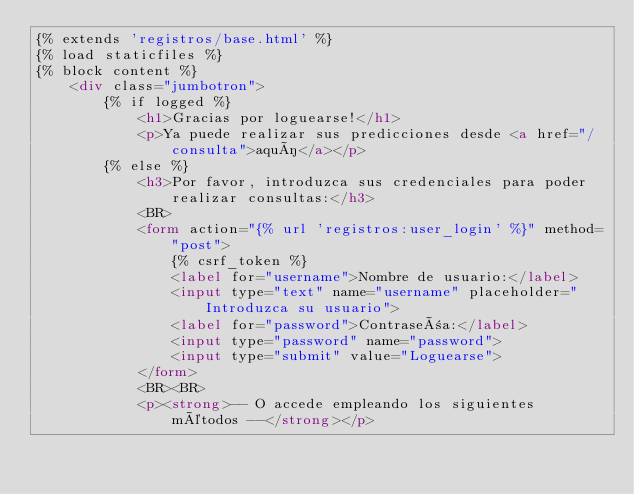<code> <loc_0><loc_0><loc_500><loc_500><_HTML_>{% extends 'registros/base.html' %}
{% load staticfiles %}
{% block content %}
    <div class="jumbotron">
        {% if logged %}
            <h1>Gracias por loguearse!</h1>
            <p>Ya puede realizar sus predicciones desde <a href="/consulta">aquí</a></p>
        {% else %}
            <h3>Por favor, introduzca sus credenciales para poder realizar consultas:</h3>
            <BR>
            <form action="{% url 'registros:user_login' %}" method="post">
                {% csrf_token %}
                <label for="username">Nombre de usuario:</label>
                <input type="text" name="username" placeholder="Introduzca su usuario">
                <label for="password">Contraseña:</label>
                <input type="password" name="password">
                <input type="submit" value="Loguearse">
            </form>
            <BR><BR>
            <p><strong>-- O accede empleando los siguientes métodos --</strong></p></code> 